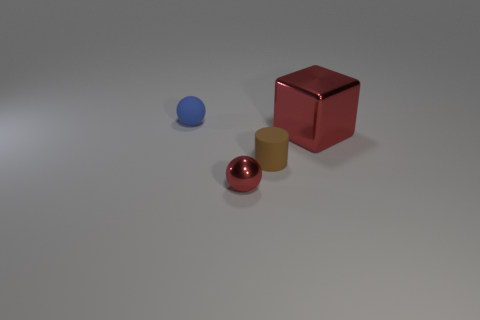There is a big red object; are there any rubber things in front of it?
Ensure brevity in your answer.  Yes. There is a rubber object that is the same size as the blue ball; what color is it?
Your answer should be very brief. Brown. What number of big red blocks have the same material as the tiny brown object?
Your answer should be compact. 0. How many other objects are there of the same size as the blue ball?
Provide a succinct answer. 2. Is there a blue rubber sphere of the same size as the cylinder?
Ensure brevity in your answer.  Yes. There is a metallic thing that is on the right side of the small red thing; is it the same color as the tiny metal sphere?
Your answer should be very brief. Yes. How many objects are either tiny cyan shiny cubes or small brown cylinders?
Your answer should be very brief. 1. There is a metal thing that is on the right side of the red metal sphere; is it the same size as the cylinder?
Your answer should be very brief. No. There is a object that is both on the left side of the block and on the right side of the tiny red ball; how big is it?
Keep it short and to the point. Small. What number of other objects are the same shape as the tiny red object?
Offer a terse response. 1. 